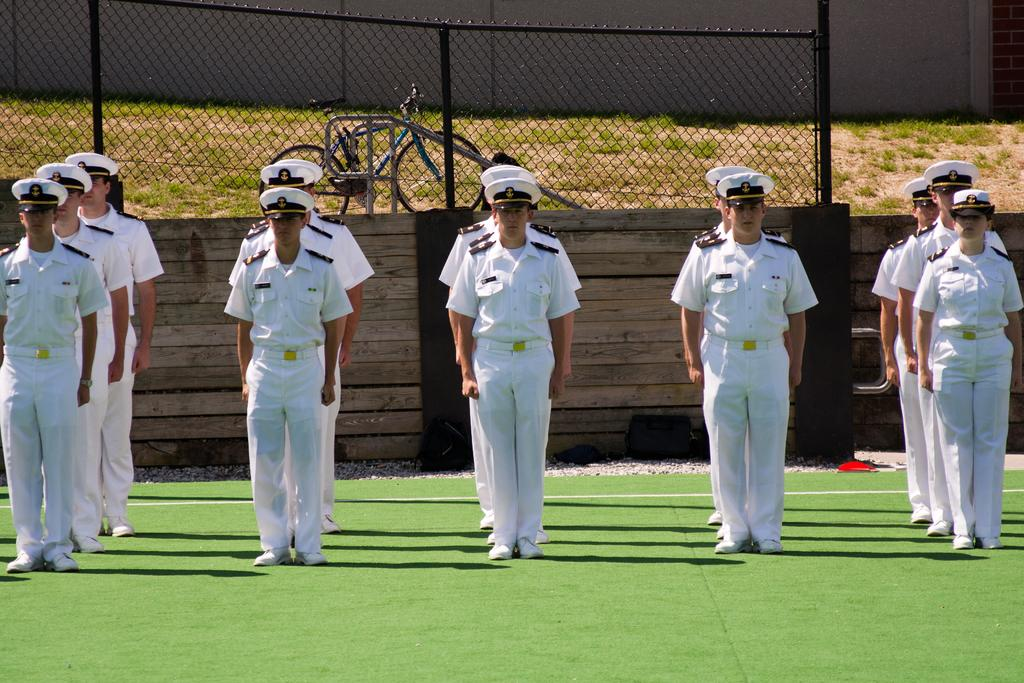Who or what is present in the image? There are people in the image. What are the people wearing? The people are wearing white uniforms and caps. What can be seen in the background of the image? There is a fence in the image. Is there any other object visible in the image? Yes, there is a bicycle at the back of the image. What type of mist can be seen surrounding the people in the image? There is no mist present in the image; the people are wearing white uniforms and caps, and there is a fence and a bicycle visible in the background. 